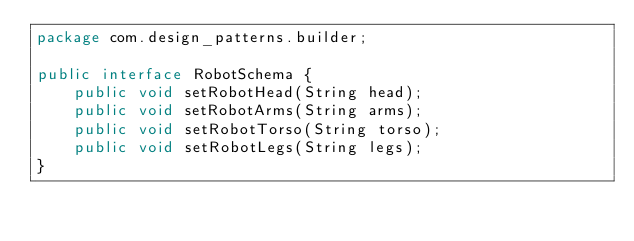Convert code to text. <code><loc_0><loc_0><loc_500><loc_500><_Java_>package com.design_patterns.builder;

public interface RobotSchema {
    public void setRobotHead(String head);
    public void setRobotArms(String arms);
    public void setRobotTorso(String torso);
    public void setRobotLegs(String legs);
}
</code> 